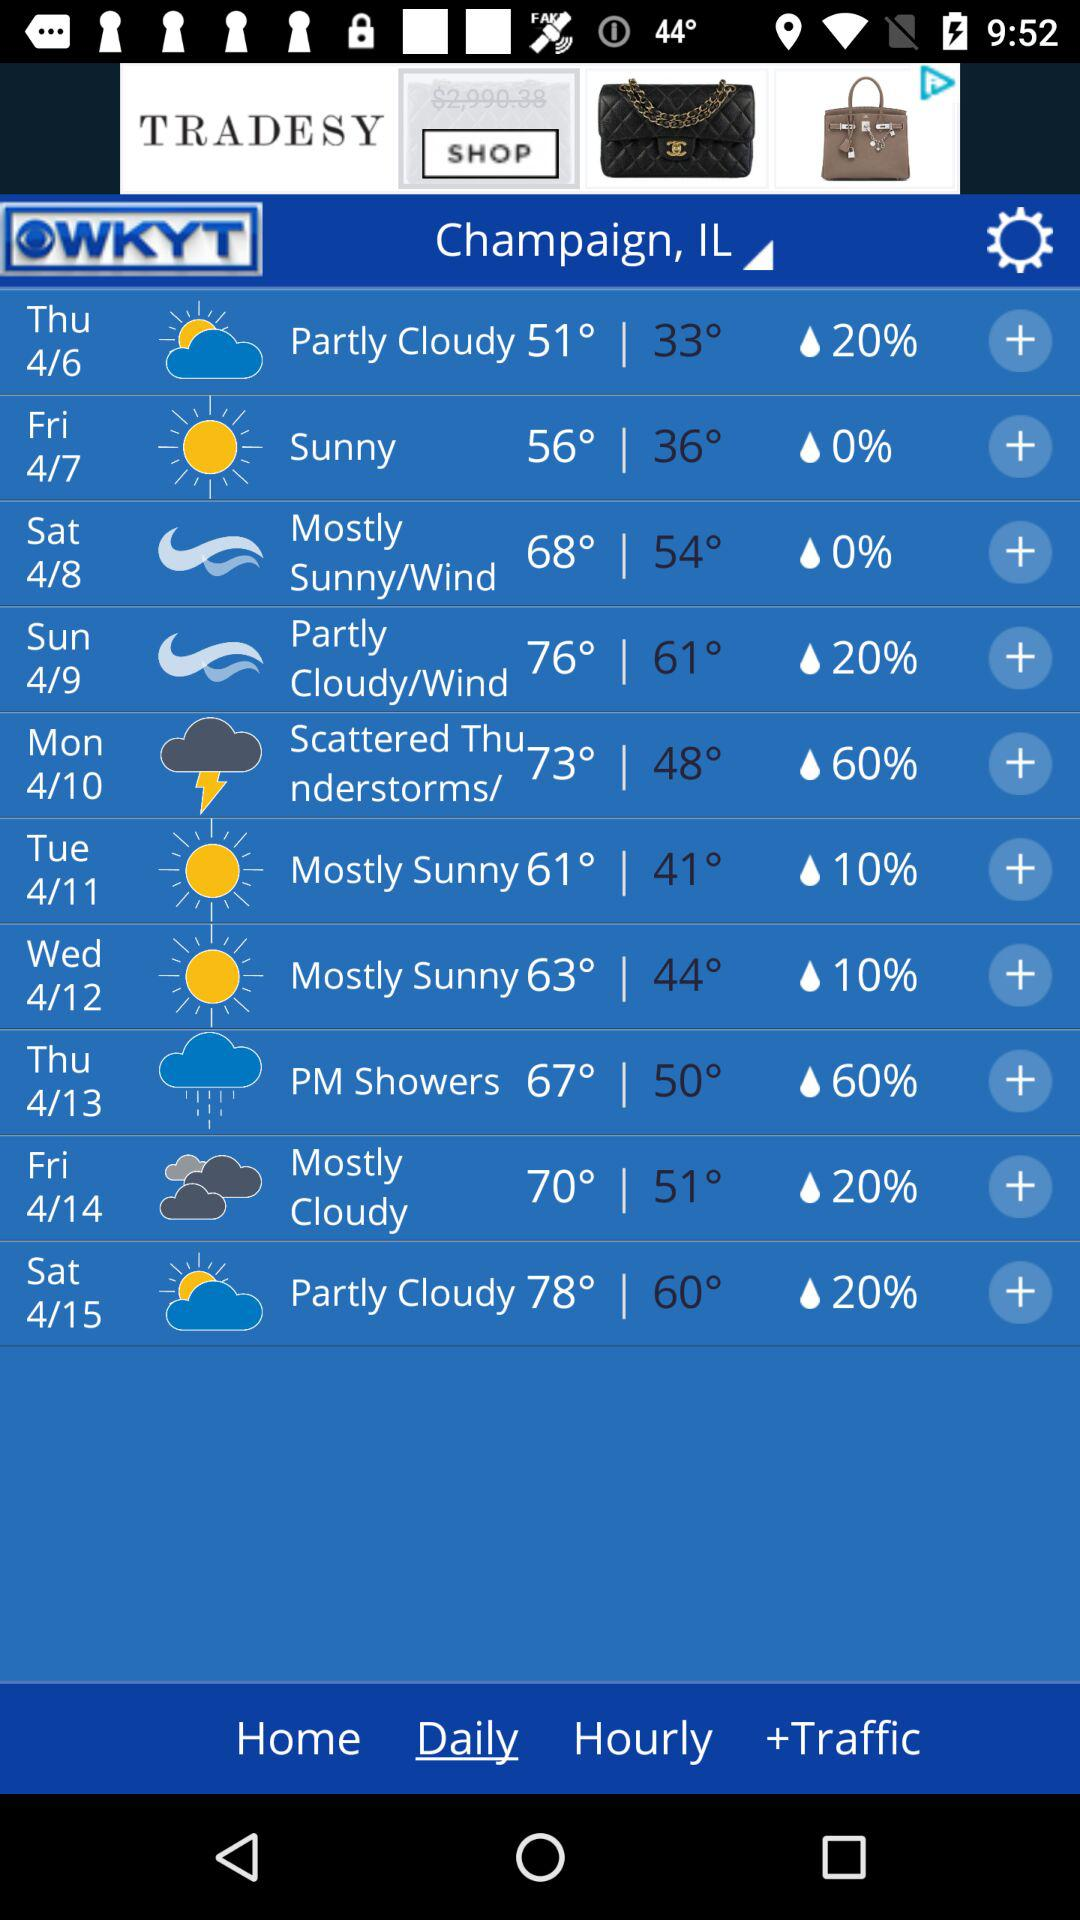How many degrees is the highest temperature for the week?
Answer the question using a single word or phrase. 78° 